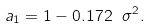<formula> <loc_0><loc_0><loc_500><loc_500>a _ { 1 } = 1 - 0 . 1 7 2 \ \sigma ^ { 2 } .</formula> 